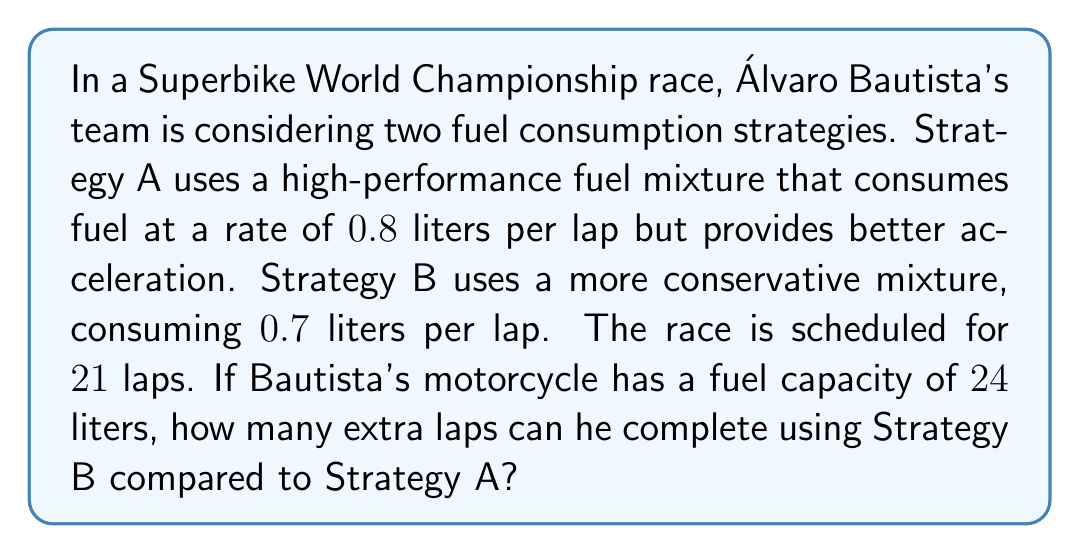Teach me how to tackle this problem. Let's approach this step-by-step:

1) First, calculate the total fuel consumption for Strategy A:
   $$\text{Fuel consumed (A)} = 0.8 \text{ L/lap} \times 21 \text{ laps} = 16.8 \text{ L}$$

2) Now, calculate the total fuel consumption for Strategy B:
   $$\text{Fuel consumed (B)} = 0.7 \text{ L/lap} \times 21 \text{ laps} = 14.7 \text{ L}$$

3) Calculate the remaining fuel for each strategy:
   $$\text{Remaining fuel (A)} = 24 \text{ L} - 16.8 \text{ L} = 7.2 \text{ L}$$
   $$\text{Remaining fuel (B)} = 24 \text{ L} - 14.7 \text{ L} = 9.3 \text{ L}$$

4) Calculate how many additional laps can be completed with the remaining fuel:
   $$\text{Additional laps (A)} = \frac{7.2 \text{ L}}{0.8 \text{ L/lap}} = 9 \text{ laps}$$
   $$\text{Additional laps (B)} = \frac{9.3 \text{ L}}{0.7 \text{ L/lap}} = 13.28 \text{ laps}$$

5) Round down to the nearest whole lap (can't complete a partial lap):
   Strategy A: 9 additional laps
   Strategy B: 13 additional laps

6) Calculate the difference:
   $$13 - 9 = 4 \text{ laps}$$

Therefore, using Strategy B, Bautista can complete 4 more laps than with Strategy A.
Answer: 4 laps 